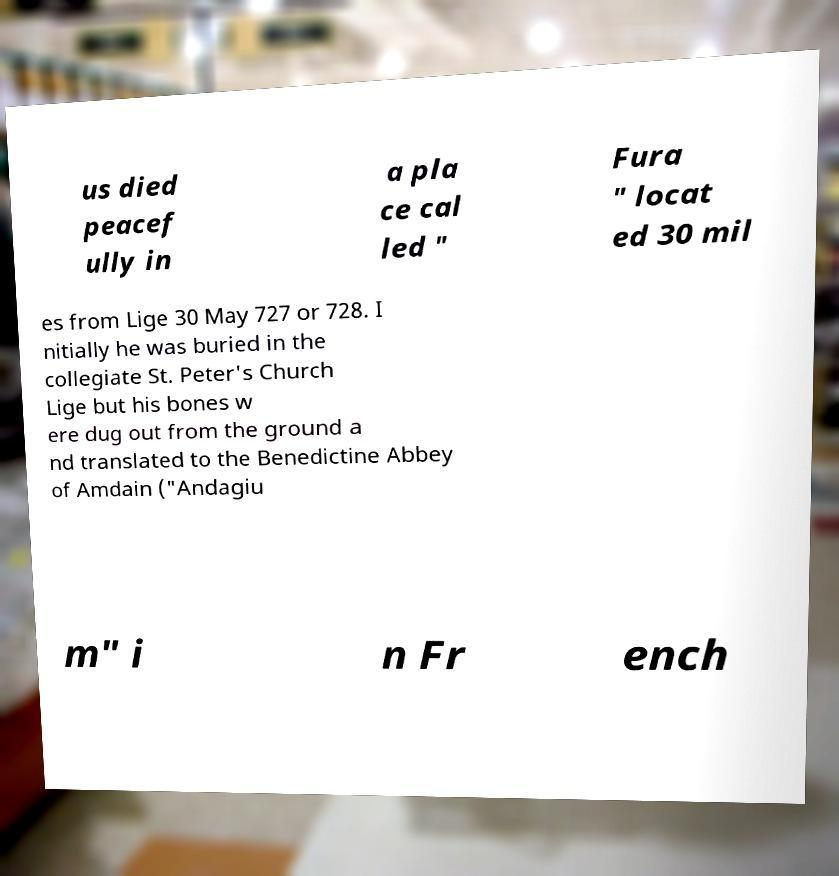Can you accurately transcribe the text from the provided image for me? us died peacef ully in a pla ce cal led " Fura " locat ed 30 mil es from Lige 30 May 727 or 728. I nitially he was buried in the collegiate St. Peter's Church Lige but his bones w ere dug out from the ground a nd translated to the Benedictine Abbey of Amdain ("Andagiu m" i n Fr ench 